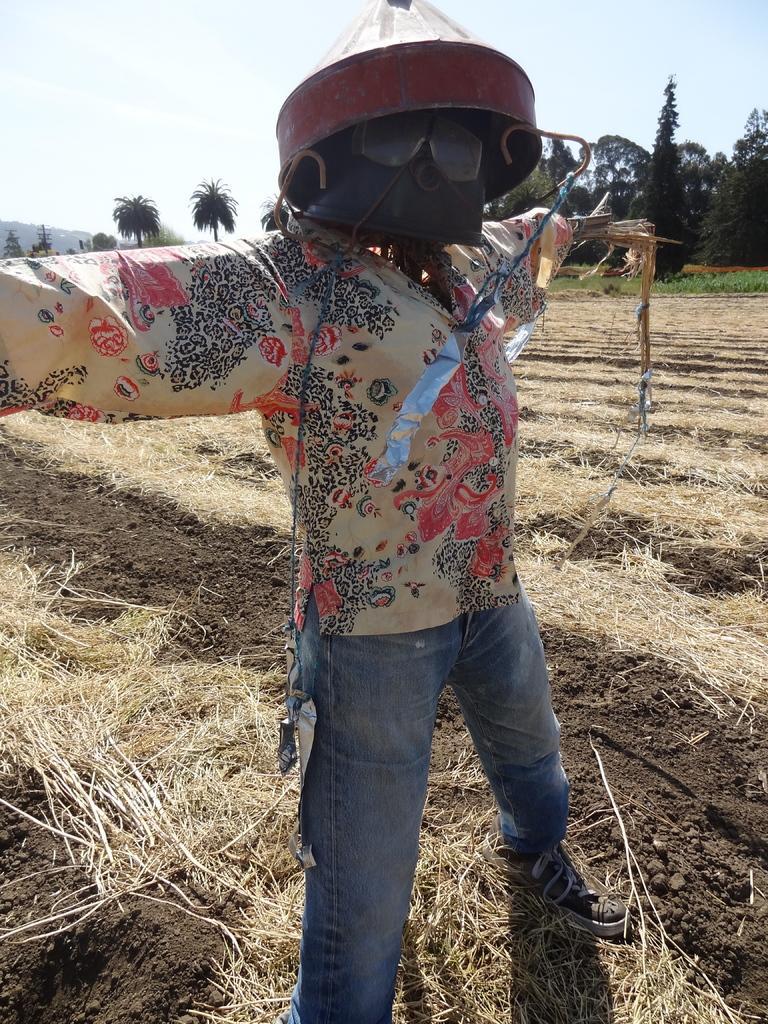In one or two sentences, can you explain what this image depicts? In this image I can see a scarecrow. At the bottom, I can see the dry grass on the ground. In the background there are many trees. At the top of the image I can see the sky. 